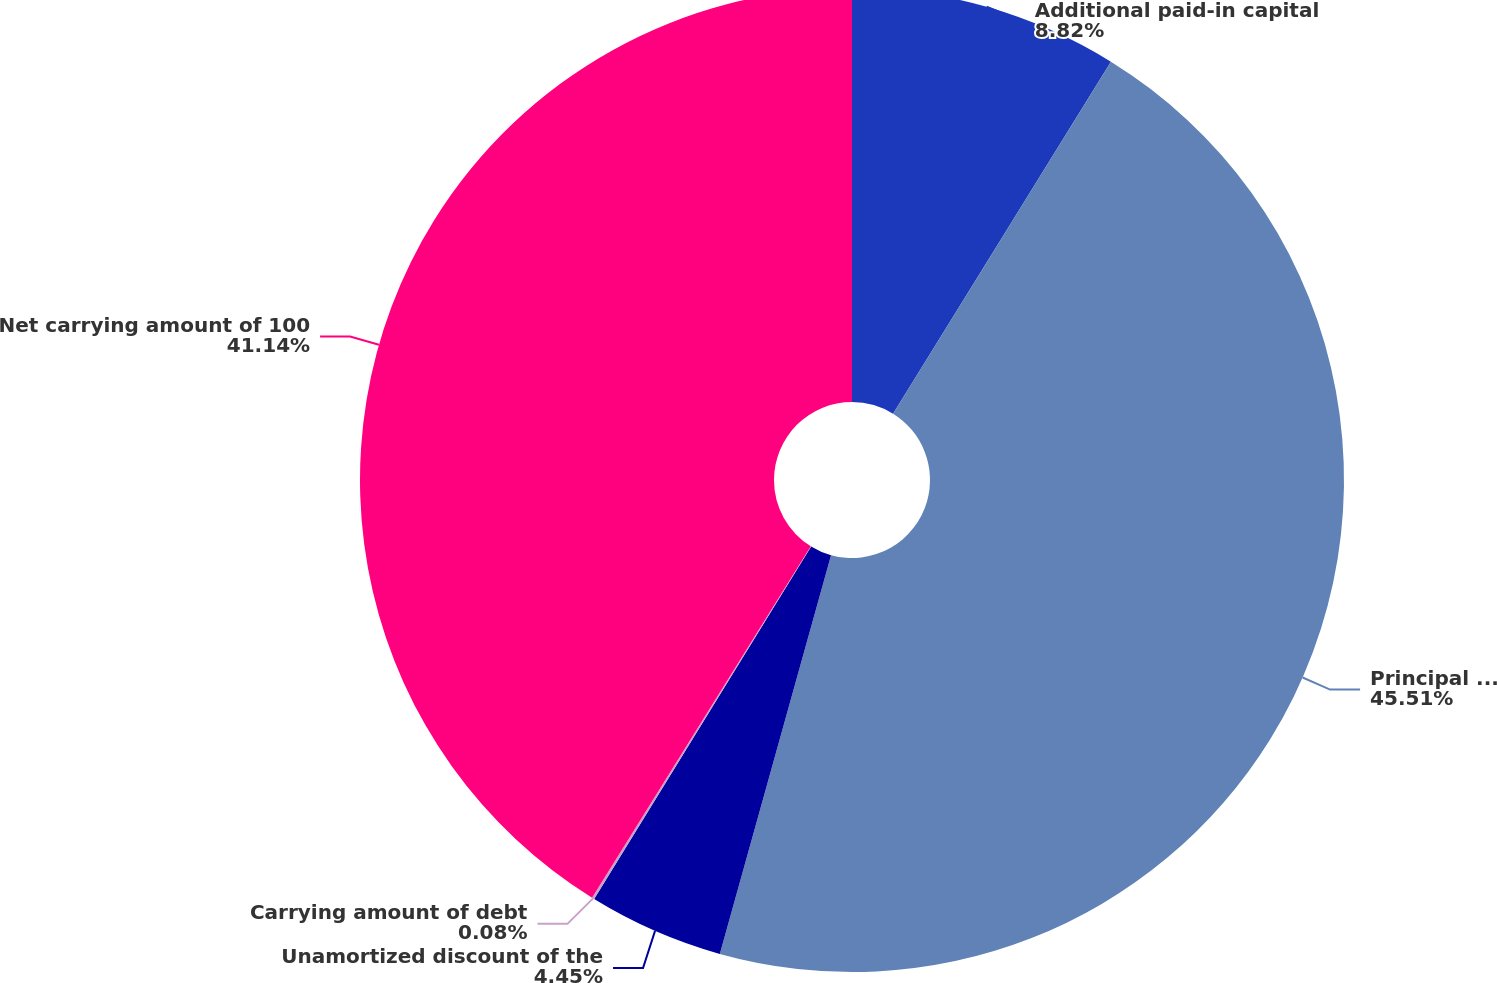<chart> <loc_0><loc_0><loc_500><loc_500><pie_chart><fcel>Additional paid-in capital<fcel>Principal amount of 100<fcel>Unamortized discount of the<fcel>Carrying amount of debt<fcel>Net carrying amount of 100<nl><fcel>8.82%<fcel>45.51%<fcel>4.45%<fcel>0.08%<fcel>41.14%<nl></chart> 